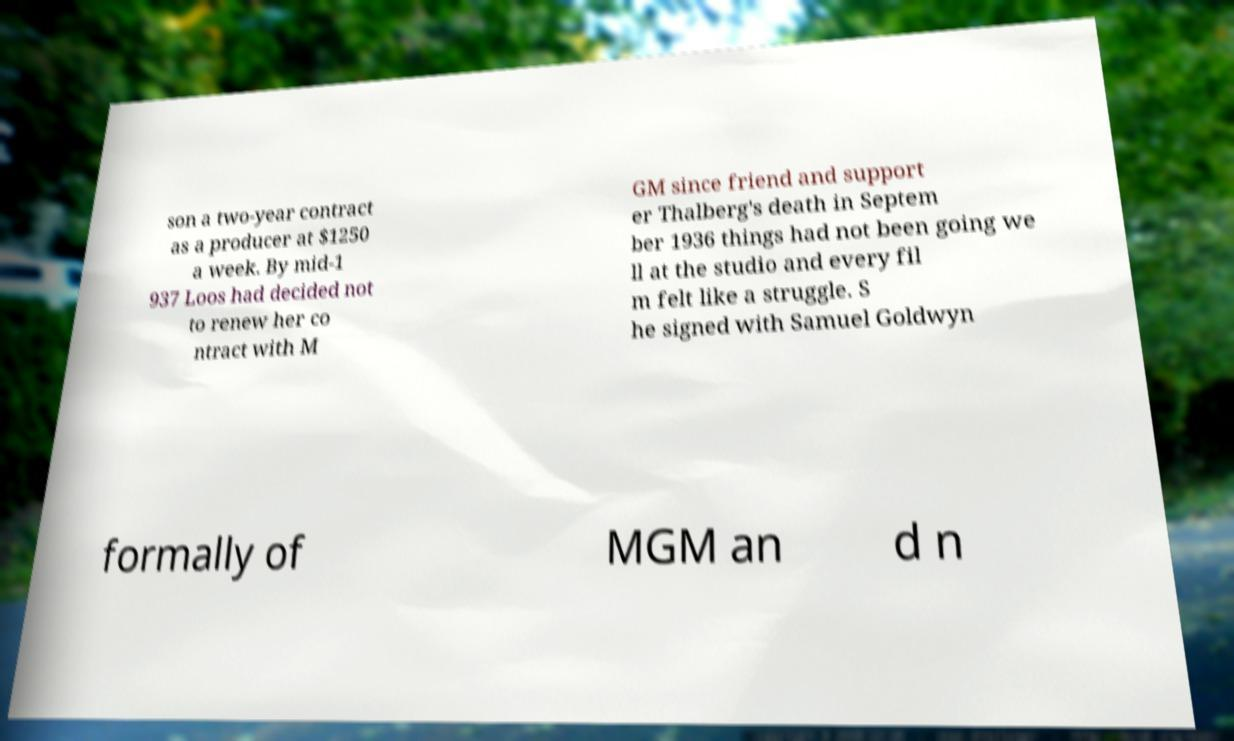Please identify and transcribe the text found in this image. son a two-year contract as a producer at $1250 a week. By mid-1 937 Loos had decided not to renew her co ntract with M GM since friend and support er Thalberg's death in Septem ber 1936 things had not been going we ll at the studio and every fil m felt like a struggle. S he signed with Samuel Goldwyn formally of MGM an d n 